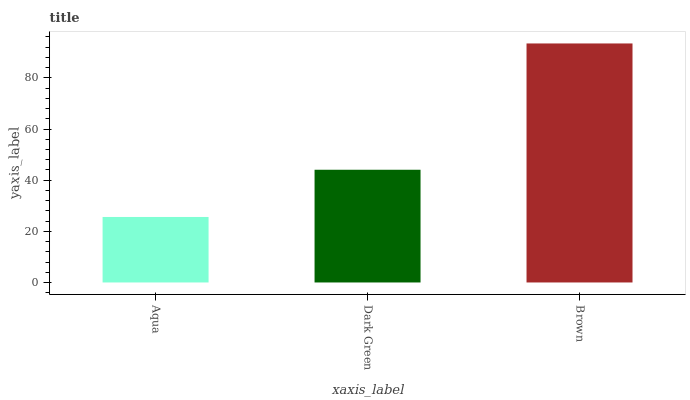Is Dark Green the minimum?
Answer yes or no. No. Is Dark Green the maximum?
Answer yes or no. No. Is Dark Green greater than Aqua?
Answer yes or no. Yes. Is Aqua less than Dark Green?
Answer yes or no. Yes. Is Aqua greater than Dark Green?
Answer yes or no. No. Is Dark Green less than Aqua?
Answer yes or no. No. Is Dark Green the high median?
Answer yes or no. Yes. Is Dark Green the low median?
Answer yes or no. Yes. Is Aqua the high median?
Answer yes or no. No. Is Brown the low median?
Answer yes or no. No. 